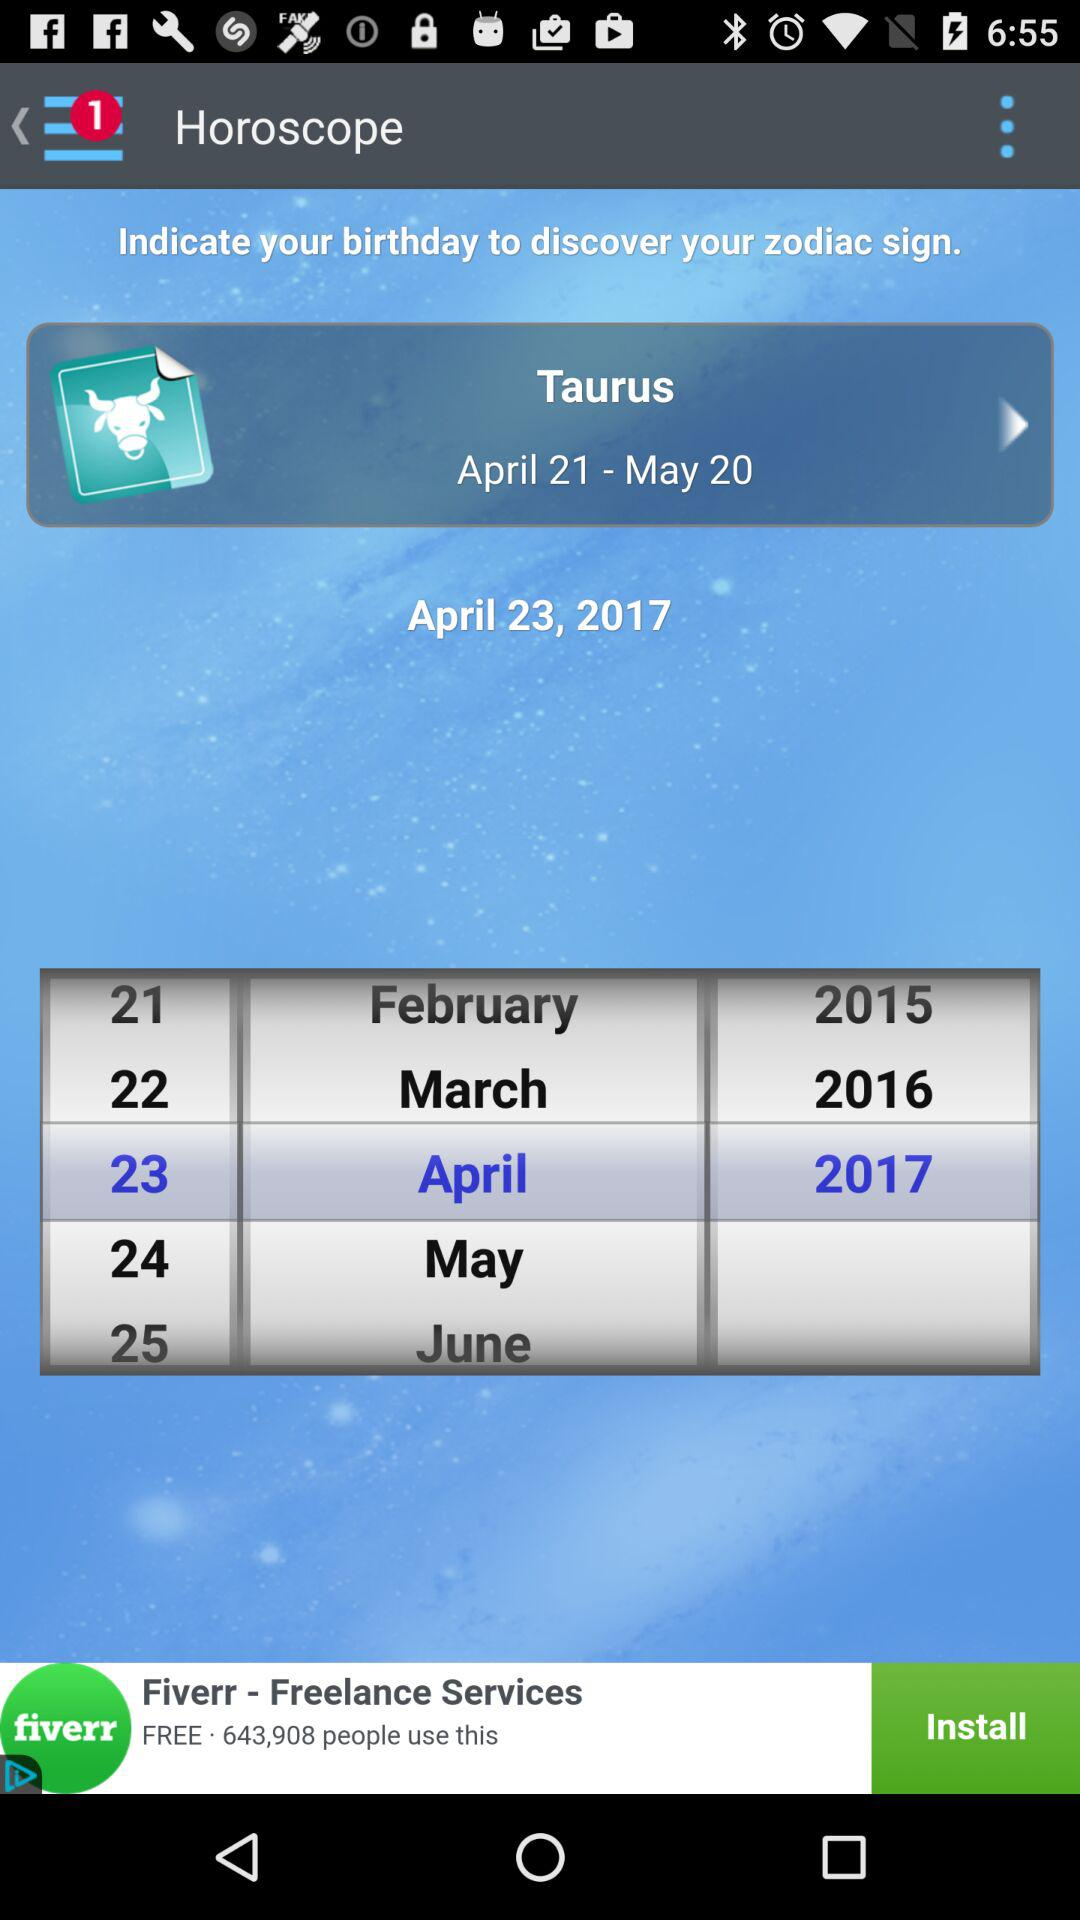What is the Horoscope?
When the provided information is insufficient, respond with <no answer>. <no answer> 